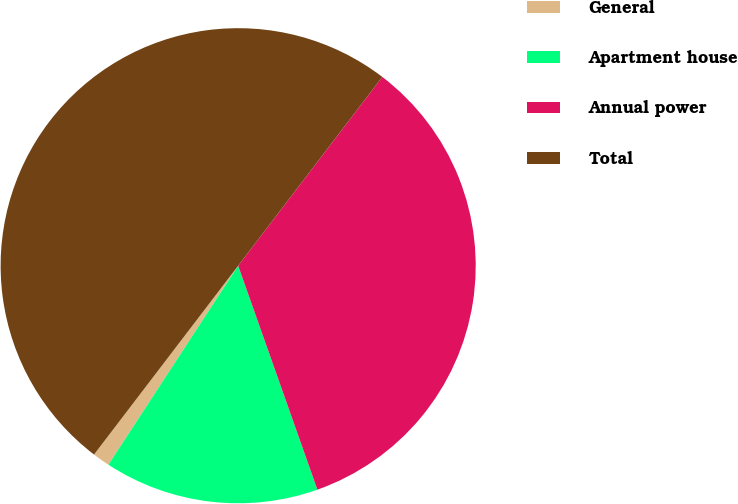Convert chart to OTSL. <chart><loc_0><loc_0><loc_500><loc_500><pie_chart><fcel>General<fcel>Apartment house<fcel>Annual power<fcel>Total<nl><fcel>1.18%<fcel>14.61%<fcel>34.21%<fcel>50.0%<nl></chart> 